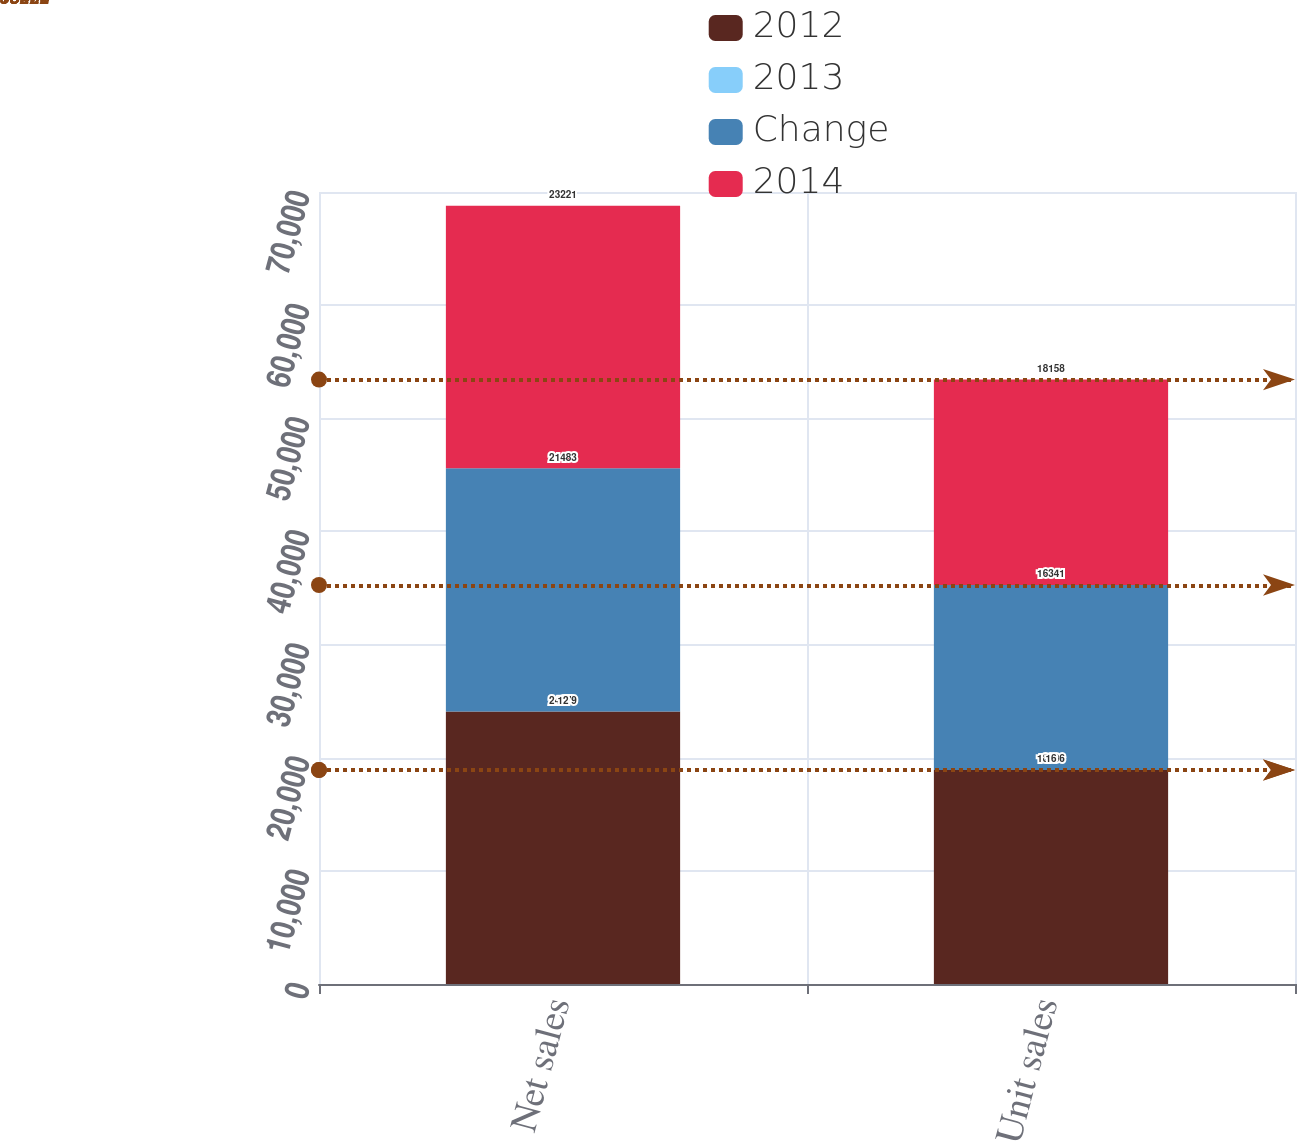<chart> <loc_0><loc_0><loc_500><loc_500><stacked_bar_chart><ecel><fcel>Net sales<fcel>Unit sales<nl><fcel>2012<fcel>24079<fcel>18906<nl><fcel>2013<fcel>12<fcel>16<nl><fcel>Change<fcel>21483<fcel>16341<nl><fcel>2014<fcel>23221<fcel>18158<nl></chart> 